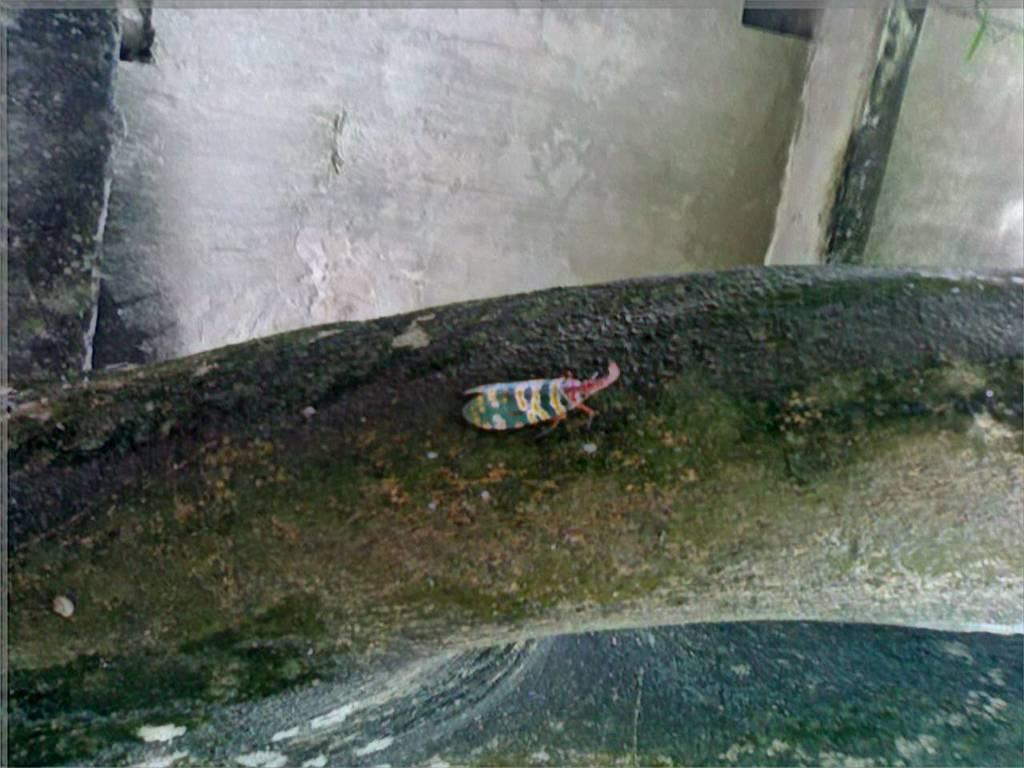What is located on the trunk of the tree in the image? There is an insect on the trunk of a tree in the image. What else can be seen in the background of the image? There are other objects visible in the background of the image, but their specific details are not mentioned in the provided facts. What type of bells can be heard ringing in the image? There is no mention of bells or any sounds in the image, so it is not possible to determine what, if any, bells might be heard. 